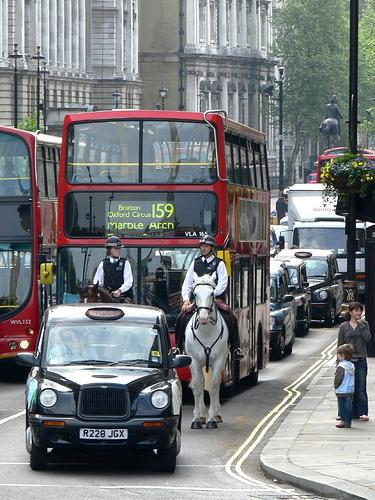Examine the image and describe one of the decorative aspects in the scene. A pole displaying a hanging plant adorned with yellow and purple flowers adds a decorative touch to the image. Count how many different objects have a description related to a horse in the image. There are six distinct objects related to horses: man on white horse, woman on brown horse, police officer on horse (two instances), rider on white horse, and statue of man on horse. Describe the location and size of the paved city sidewalk, and what can be observed on it. The paved city sidewalk, measured at 259x364 pixels, is located to the side of the street. People can be seen standing with a woman, a child, and a little boy wearing a light blue jacket. Identify the main means of transportation found in the image and their colors. The main means of transportation are taxis (black), double-decker buses (red), a small compact car (color unspecified), and horses (white and brown). State the number of the red double-decker bus and describe its part with an electronic display. The red double-decker bus has the number 159, and the electronic bus destination sign can be found on it. What kind of flowers are on the street pole, and what are their colors? The flowers on the street pole are yellow and purple; it's mentioned both as "yellow flowers" and "plant with yellow and purple flowers." Identify one interaction between people and other objects or beings within the scene. One interaction is a police officer riding a horse in the street, in close proximity to other vehicles and pedestrians. What are the two noticeable things about the black taxi in the image? The black taxi has a white license plate with black letters and a yellow registration sticker on it. List three types of people found in the image standing on the sidewalk. Three types of people are a woman, a little boy in a light blue jacket, and a woman with a child. What kind of street marking can be found in the image, and where is it located? There are two yellow squiggly lines, also referred to as wavy double lines, painted on the street, located at position 220x337 pixels. Does the paved city sidewalk have colorful tiles? There is information about a paved city sidewalk, but nothing mentioned about the presence of colorful tiles on it. Are the two people riding horses in the street both wearing blue jackets? There is information about two people riding horses in the street, but there is no information specifically about their clothing, especially not about wearing blue jackets. Are the yellow flowers on the street pole actually roses? There are mentions of yellow flowers on a street pole, but there is no information specifying their species, so we cannot conclude that they are roses. Is the man on the white horse wearing a green hat? There are mentions of a man on a white horse, but there is no information about him wearing a hat, let alone a green one. Is the woman standing on the sidewalk holding an umbrella? There is information about a woman standing on the sidewalk, but no information about her holding an umbrella. Do the doors on the red bus have rainbow-colored handles? There are mentions of doors on a red bus, but there is no information provided about the color of the handles, so we cannot claim they are rainbow-colored. 